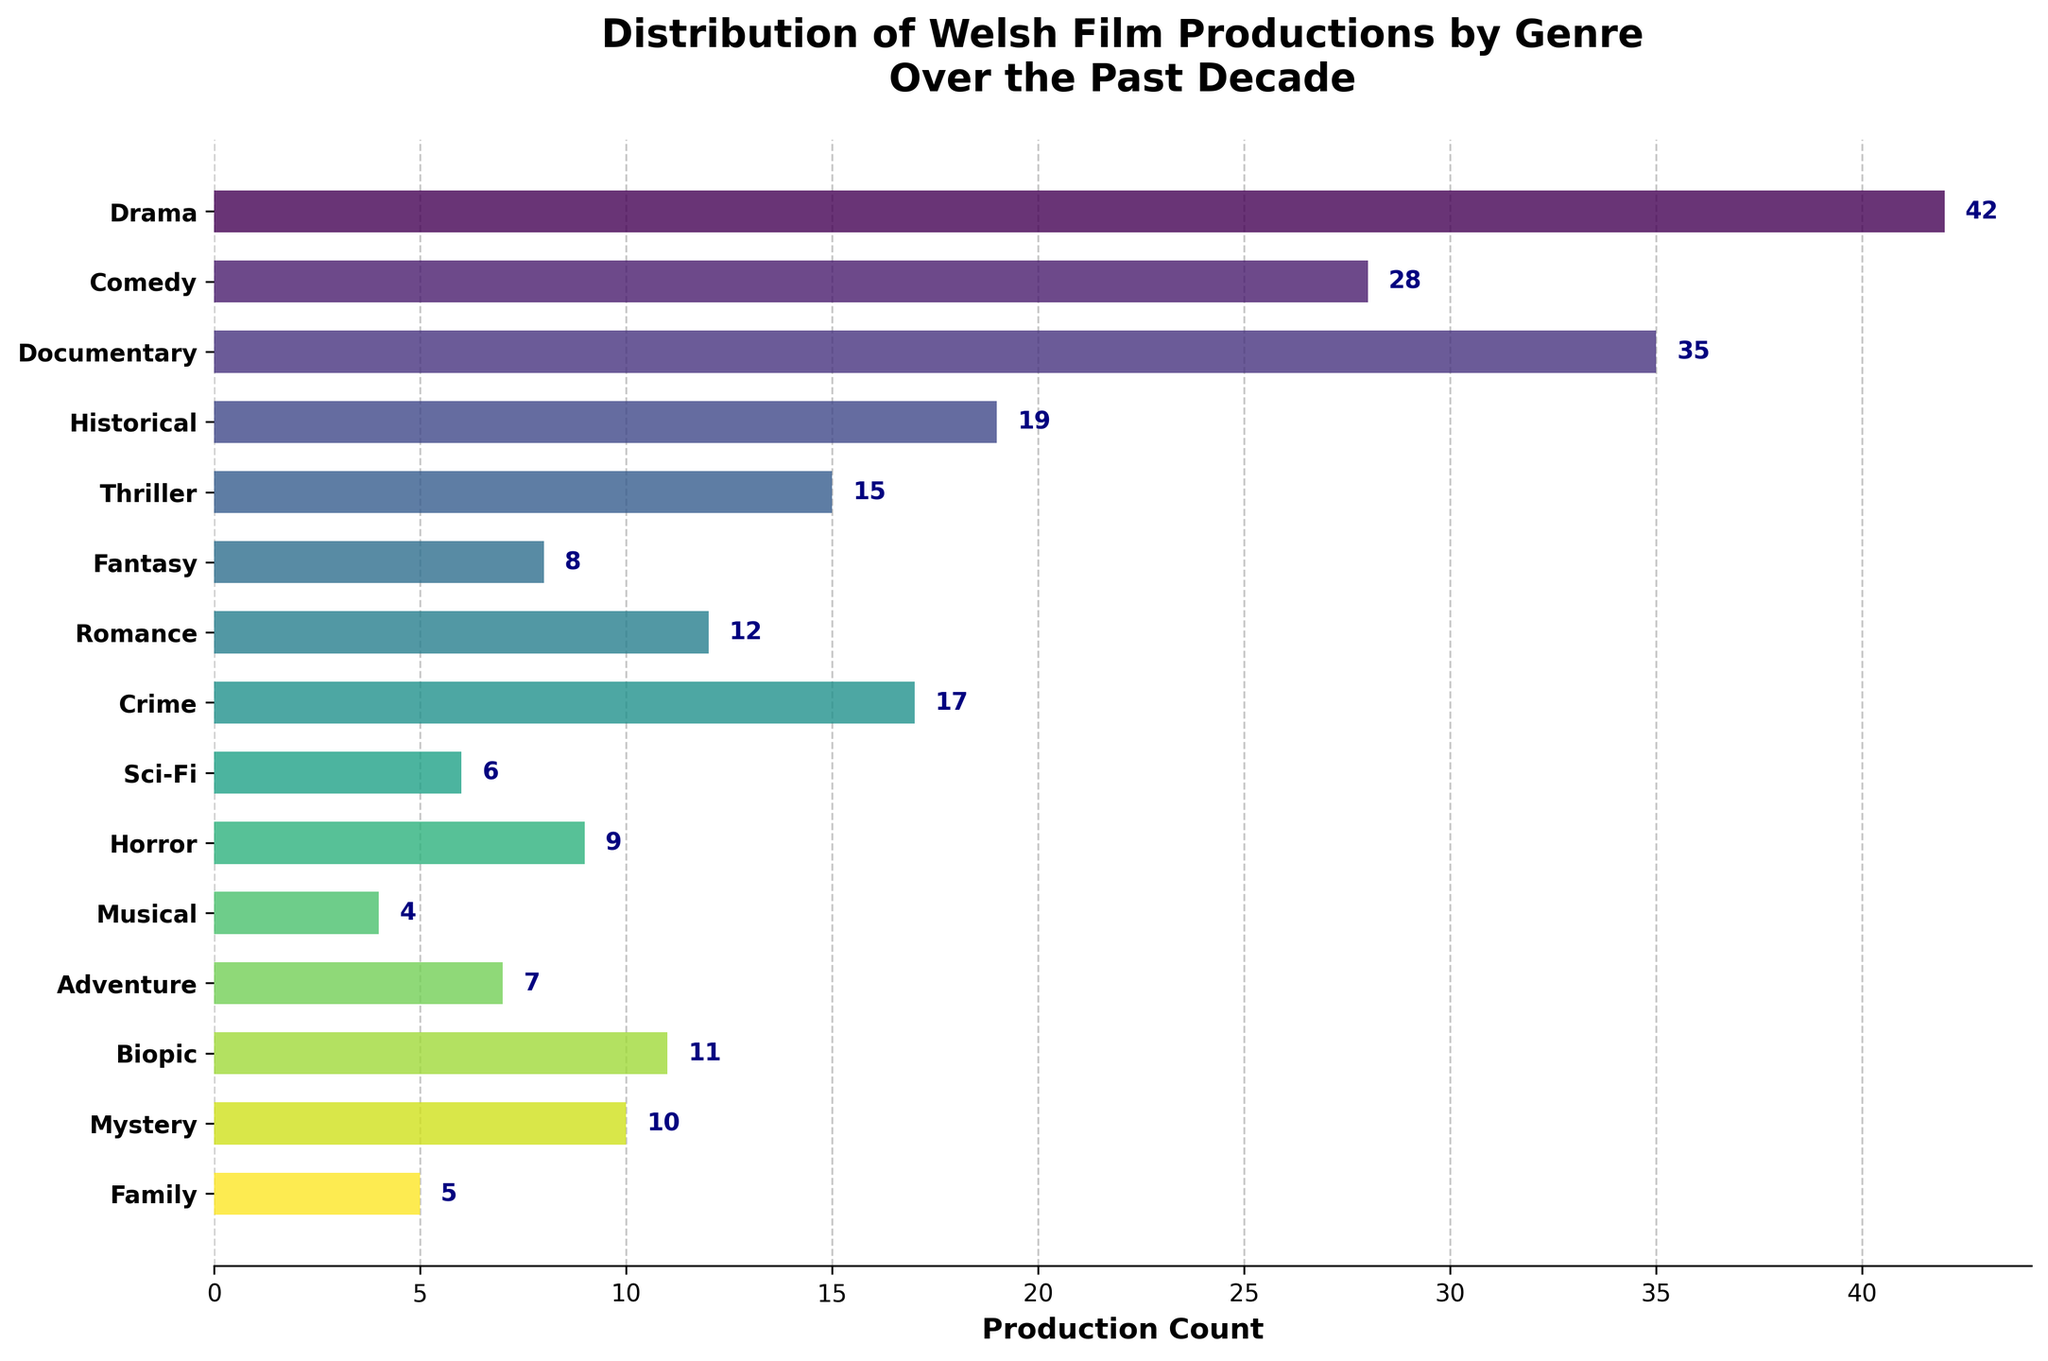What's the most common genre of Welsh film productions over the past decade? The genre with the highest bar in the plot represents the most common genre. Here, Drama has the longest bar.
Answer: Drama How many Welsh films were produced in the thriller genre? The count for each genre is displayed at the end of each bar. For Thriller, it shows 15.
Answer: 15 What is the total number of productions for Drama, Comedy, and Documentary genres combined? Sum the production counts for Drama (42), Comedy (28), and Documentary (35). \(42 + 28 + 35 = 105\)
Answer: 105 Which genre has a production count exactly one less than the Romance genre? Romance has a production count of 12. The genre with a count of 11 is Biopic.
Answer: Biopic Of the genres Mystery, Family, and Sci-Fi, which has the fewest film productions? Compare the production counts: Mystery (10), Family (5), and Sci-Fi (6). Family has the smallest count.
Answer: Family How many more Drama films were produced compared to Historical films? Subtract the production count of Historical (19) from that of Drama (42): \(42 - 19 = 23\)
Answer: 23 What is the median production count for all the genres? To find the median, list all the counts in ascending order and find the middle value. Ordered counts: [4, 5, 6, 7, 8, 9, 10, 11, 12, 15, 17, 19, 28, 35, 42]. The median is the middle value, 11.
Answer: 11 Which genre has half the number of productions as the Adventure genre? The Adventure genre has a production count of 7. Half of 7 is 3.5, which rounds to 4. The Musical genre has 4 productions.
Answer: Musical Is there any genre with exactly 9 film productions? Yes, the count of Horror genre is exactly 9.
Answer: Horror 